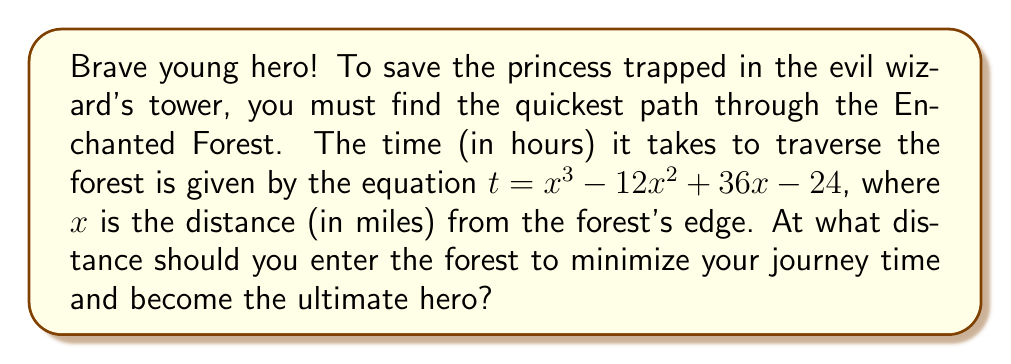Can you solve this math problem? Let's approach this heroic quest step-by-step:

1) To find the minimum time, we need to find where the derivative of $t$ with respect to $x$ equals zero.

2) Let's find the derivative:
   $$\frac{dt}{dx} = 3x^2 - 24x + 36$$

3) Set this equal to zero:
   $$3x^2 - 24x + 36 = 0$$

4) This is a quadratic equation. We can solve it using the quadratic formula:
   $$x = \frac{-b \pm \sqrt{b^2 - 4ac}}{2a}$$
   where $a = 3$, $b = -24$, and $c = 36$

5) Plugging in these values:
   $$x = \frac{24 \pm \sqrt{(-24)^2 - 4(3)(36)}}{2(3)}$$
   $$x = \frac{24 \pm \sqrt{576 - 432}}{6}$$
   $$x = \frac{24 \pm \sqrt{144}}{6}$$
   $$x = \frac{24 \pm 12}{6}$$

6) This gives us two solutions:
   $$x = \frac{24 + 12}{6} = 6$$ or $$x = \frac{24 - 12}{6} = 2$$

7) To determine which of these gives the minimum (rather than maximum) time, we can check the second derivative:
   $$\frac{d^2t}{dx^2} = 6x - 24$$

8) At $x = 6$:
   $$\frac{d^2t}{dx^2} = 6(6) - 24 = 12 > 0$$
   This is positive, indicating a minimum.

Therefore, the hero should enter the forest 6 miles from the edge to minimize the journey time.
Answer: 6 miles 